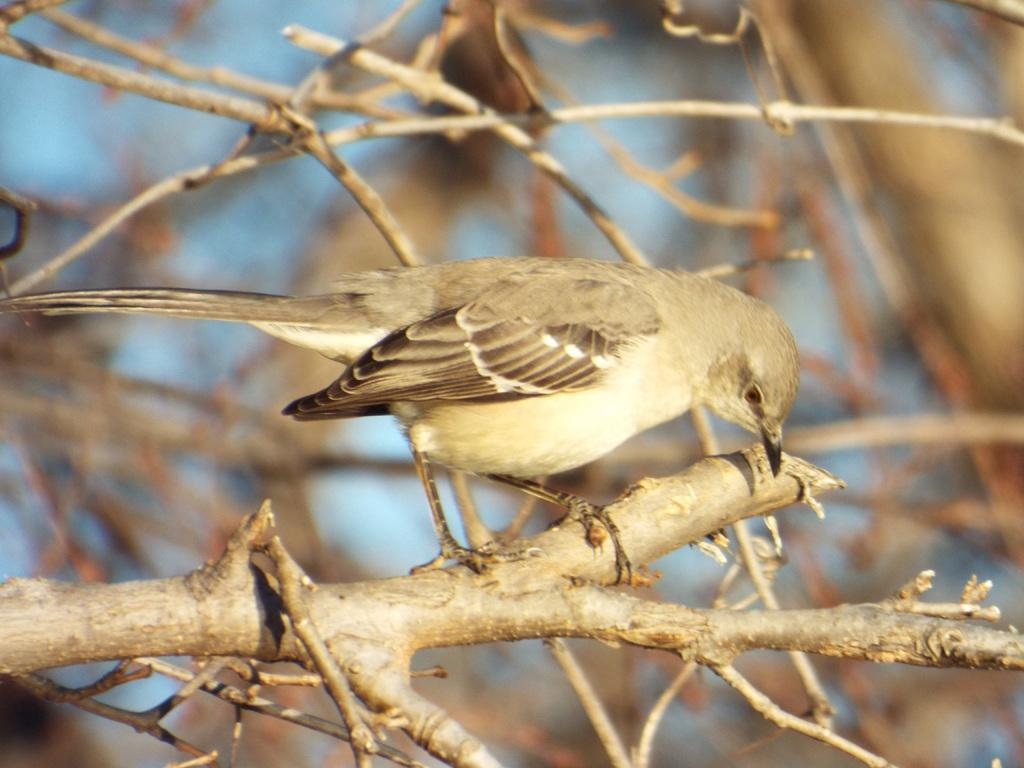What type of bird is in the image? There is a sparrow in the image. Where is the sparrow located? The sparrow is sitting on a trunk. What can be seen in the background of the image? There are twigs in the backdrop of the image. What type of zebra can be seen in the image? There is no zebra present in the image; it features a sparrow sitting on a trunk. What is the sparrow carrying in the image? The sparrow is not carrying a bag or any other object in the image. 